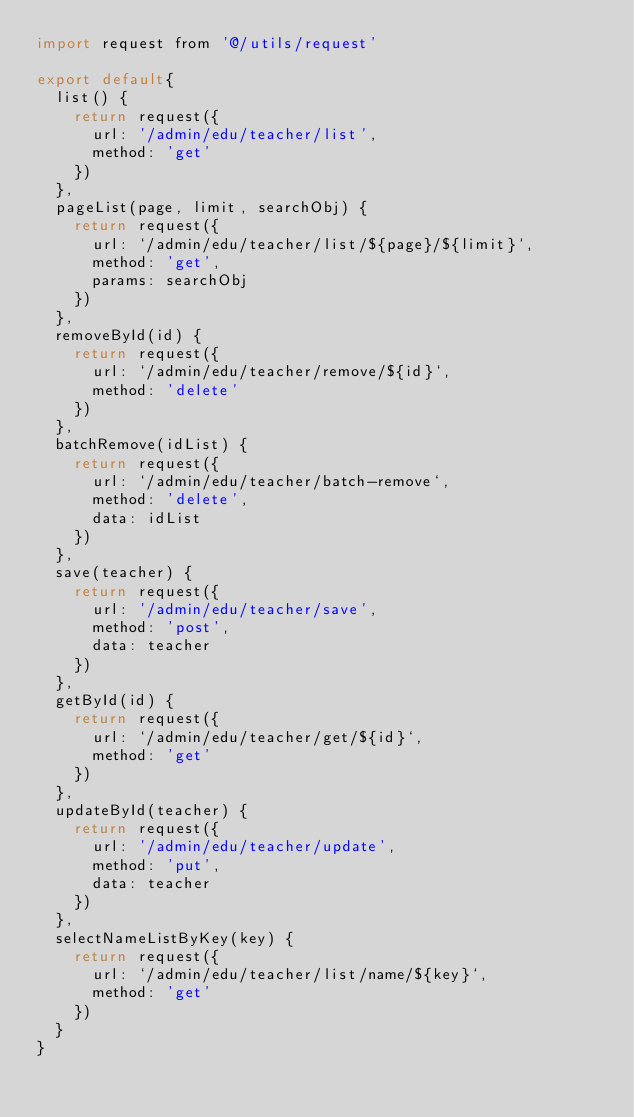<code> <loc_0><loc_0><loc_500><loc_500><_JavaScript_>import request from '@/utils/request'

export default{
  list() {
    return request({
      url: '/admin/edu/teacher/list',
      method: 'get'
    })
  },
  pageList(page, limit, searchObj) {
    return request({
      url: `/admin/edu/teacher/list/${page}/${limit}`,
      method: 'get',
      params: searchObj
    })
  },
  removeById(id) {
    return request({
      url: `/admin/edu/teacher/remove/${id}`,
      method: 'delete'
    })
  },
  batchRemove(idList) {
    return request({
      url: `/admin/edu/teacher/batch-remove`,
      method: 'delete',
      data: idList
    })
  },
  save(teacher) {
    return request({
      url: '/admin/edu/teacher/save',
      method: 'post',
      data: teacher
    })
  },
  getById(id) {
    return request({
      url: `/admin/edu/teacher/get/${id}`,
      method: 'get'
    })
  },
  updateById(teacher) {
    return request({
      url: '/admin/edu/teacher/update',
      method: 'put',
      data: teacher
    })
  },
  selectNameListByKey(key) {
    return request({
      url: `/admin/edu/teacher/list/name/${key}`,
      method: 'get'
    })
  }
}
</code> 